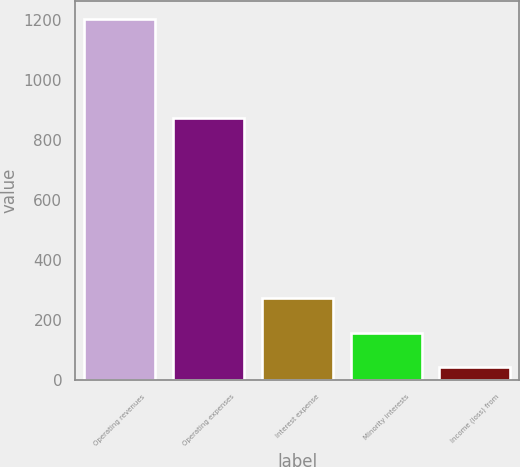Convert chart to OTSL. <chart><loc_0><loc_0><loc_500><loc_500><bar_chart><fcel>Operating revenues<fcel>Operating expenses<fcel>Interest expense<fcel>Minority interests<fcel>Income (loss) from<nl><fcel>1202<fcel>875<fcel>274.8<fcel>158.9<fcel>43<nl></chart> 